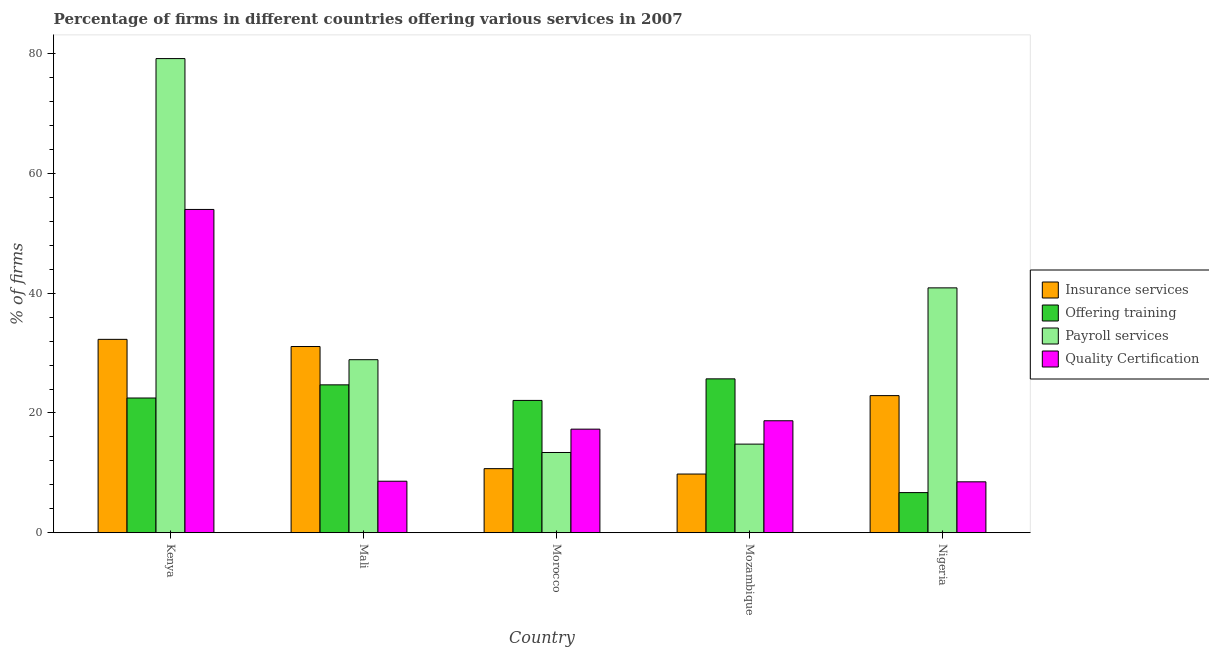How many different coloured bars are there?
Your answer should be compact. 4. Are the number of bars on each tick of the X-axis equal?
Provide a short and direct response. Yes. What is the label of the 3rd group of bars from the left?
Your response must be concise. Morocco. In how many cases, is the number of bars for a given country not equal to the number of legend labels?
Your answer should be very brief. 0. What is the percentage of firms offering payroll services in Mali?
Make the answer very short. 28.9. Across all countries, what is the maximum percentage of firms offering training?
Your answer should be compact. 25.7. Across all countries, what is the minimum percentage of firms offering insurance services?
Provide a succinct answer. 9.8. In which country was the percentage of firms offering quality certification maximum?
Your answer should be compact. Kenya. In which country was the percentage of firms offering quality certification minimum?
Your response must be concise. Nigeria. What is the total percentage of firms offering training in the graph?
Keep it short and to the point. 101.7. What is the difference between the percentage of firms offering quality certification in Kenya and that in Morocco?
Your answer should be very brief. 36.7. What is the difference between the percentage of firms offering training in Mali and the percentage of firms offering quality certification in Nigeria?
Offer a very short reply. 16.2. What is the average percentage of firms offering insurance services per country?
Offer a terse response. 21.36. What is the difference between the percentage of firms offering training and percentage of firms offering payroll services in Mozambique?
Your answer should be very brief. 10.9. What is the ratio of the percentage of firms offering quality certification in Mali to that in Mozambique?
Offer a very short reply. 0.46. Is the percentage of firms offering payroll services in Mali less than that in Morocco?
Make the answer very short. No. Is the difference between the percentage of firms offering training in Kenya and Mozambique greater than the difference between the percentage of firms offering payroll services in Kenya and Mozambique?
Provide a succinct answer. No. What is the difference between the highest and the second highest percentage of firms offering quality certification?
Make the answer very short. 35.3. What is the difference between the highest and the lowest percentage of firms offering quality certification?
Offer a terse response. 45.5. In how many countries, is the percentage of firms offering insurance services greater than the average percentage of firms offering insurance services taken over all countries?
Give a very brief answer. 3. What does the 2nd bar from the left in Kenya represents?
Ensure brevity in your answer.  Offering training. What does the 2nd bar from the right in Morocco represents?
Make the answer very short. Payroll services. How many bars are there?
Your answer should be very brief. 20. How many countries are there in the graph?
Provide a short and direct response. 5. What is the difference between two consecutive major ticks on the Y-axis?
Your answer should be compact. 20. Does the graph contain grids?
Your answer should be compact. No. How many legend labels are there?
Your answer should be compact. 4. How are the legend labels stacked?
Your response must be concise. Vertical. What is the title of the graph?
Ensure brevity in your answer.  Percentage of firms in different countries offering various services in 2007. Does "Self-employed" appear as one of the legend labels in the graph?
Make the answer very short. No. What is the label or title of the Y-axis?
Ensure brevity in your answer.  % of firms. What is the % of firms of Insurance services in Kenya?
Provide a short and direct response. 32.3. What is the % of firms of Payroll services in Kenya?
Give a very brief answer. 79.2. What is the % of firms in Insurance services in Mali?
Keep it short and to the point. 31.1. What is the % of firms of Offering training in Mali?
Give a very brief answer. 24.7. What is the % of firms of Payroll services in Mali?
Provide a succinct answer. 28.9. What is the % of firms in Insurance services in Morocco?
Provide a short and direct response. 10.7. What is the % of firms in Offering training in Morocco?
Offer a terse response. 22.1. What is the % of firms of Insurance services in Mozambique?
Ensure brevity in your answer.  9.8. What is the % of firms in Offering training in Mozambique?
Your answer should be very brief. 25.7. What is the % of firms of Quality Certification in Mozambique?
Ensure brevity in your answer.  18.7. What is the % of firms of Insurance services in Nigeria?
Make the answer very short. 22.9. What is the % of firms of Offering training in Nigeria?
Ensure brevity in your answer.  6.7. What is the % of firms of Payroll services in Nigeria?
Make the answer very short. 40.9. Across all countries, what is the maximum % of firms in Insurance services?
Give a very brief answer. 32.3. Across all countries, what is the maximum % of firms of Offering training?
Provide a succinct answer. 25.7. Across all countries, what is the maximum % of firms in Payroll services?
Ensure brevity in your answer.  79.2. Across all countries, what is the minimum % of firms in Insurance services?
Your response must be concise. 9.8. Across all countries, what is the minimum % of firms of Offering training?
Your answer should be very brief. 6.7. Across all countries, what is the minimum % of firms in Payroll services?
Offer a terse response. 13.4. Across all countries, what is the minimum % of firms of Quality Certification?
Offer a terse response. 8.5. What is the total % of firms of Insurance services in the graph?
Provide a short and direct response. 106.8. What is the total % of firms in Offering training in the graph?
Keep it short and to the point. 101.7. What is the total % of firms of Payroll services in the graph?
Offer a terse response. 177.2. What is the total % of firms of Quality Certification in the graph?
Make the answer very short. 107.1. What is the difference between the % of firms of Offering training in Kenya and that in Mali?
Your response must be concise. -2.2. What is the difference between the % of firms in Payroll services in Kenya and that in Mali?
Keep it short and to the point. 50.3. What is the difference between the % of firms in Quality Certification in Kenya and that in Mali?
Your answer should be very brief. 45.4. What is the difference between the % of firms of Insurance services in Kenya and that in Morocco?
Make the answer very short. 21.6. What is the difference between the % of firms in Payroll services in Kenya and that in Morocco?
Make the answer very short. 65.8. What is the difference between the % of firms of Quality Certification in Kenya and that in Morocco?
Offer a terse response. 36.7. What is the difference between the % of firms in Insurance services in Kenya and that in Mozambique?
Provide a succinct answer. 22.5. What is the difference between the % of firms in Payroll services in Kenya and that in Mozambique?
Offer a very short reply. 64.4. What is the difference between the % of firms of Quality Certification in Kenya and that in Mozambique?
Provide a short and direct response. 35.3. What is the difference between the % of firms of Payroll services in Kenya and that in Nigeria?
Your answer should be compact. 38.3. What is the difference between the % of firms in Quality Certification in Kenya and that in Nigeria?
Provide a succinct answer. 45.5. What is the difference between the % of firms of Insurance services in Mali and that in Morocco?
Offer a very short reply. 20.4. What is the difference between the % of firms of Offering training in Mali and that in Morocco?
Provide a succinct answer. 2.6. What is the difference between the % of firms in Quality Certification in Mali and that in Morocco?
Give a very brief answer. -8.7. What is the difference between the % of firms in Insurance services in Mali and that in Mozambique?
Provide a short and direct response. 21.3. What is the difference between the % of firms of Payroll services in Mali and that in Mozambique?
Give a very brief answer. 14.1. What is the difference between the % of firms in Quality Certification in Mali and that in Mozambique?
Your response must be concise. -10.1. What is the difference between the % of firms in Insurance services in Mali and that in Nigeria?
Provide a succinct answer. 8.2. What is the difference between the % of firms in Payroll services in Mali and that in Nigeria?
Your answer should be compact. -12. What is the difference between the % of firms of Quality Certification in Mali and that in Nigeria?
Your response must be concise. 0.1. What is the difference between the % of firms in Quality Certification in Morocco and that in Mozambique?
Give a very brief answer. -1.4. What is the difference between the % of firms in Payroll services in Morocco and that in Nigeria?
Make the answer very short. -27.5. What is the difference between the % of firms in Quality Certification in Morocco and that in Nigeria?
Offer a terse response. 8.8. What is the difference between the % of firms in Payroll services in Mozambique and that in Nigeria?
Give a very brief answer. -26.1. What is the difference between the % of firms in Insurance services in Kenya and the % of firms in Offering training in Mali?
Ensure brevity in your answer.  7.6. What is the difference between the % of firms in Insurance services in Kenya and the % of firms in Quality Certification in Mali?
Ensure brevity in your answer.  23.7. What is the difference between the % of firms of Offering training in Kenya and the % of firms of Quality Certification in Mali?
Your response must be concise. 13.9. What is the difference between the % of firms of Payroll services in Kenya and the % of firms of Quality Certification in Mali?
Offer a very short reply. 70.6. What is the difference between the % of firms in Insurance services in Kenya and the % of firms in Offering training in Morocco?
Your response must be concise. 10.2. What is the difference between the % of firms in Insurance services in Kenya and the % of firms in Quality Certification in Morocco?
Offer a terse response. 15. What is the difference between the % of firms in Payroll services in Kenya and the % of firms in Quality Certification in Morocco?
Your answer should be compact. 61.9. What is the difference between the % of firms of Insurance services in Kenya and the % of firms of Offering training in Mozambique?
Provide a succinct answer. 6.6. What is the difference between the % of firms in Insurance services in Kenya and the % of firms in Payroll services in Mozambique?
Make the answer very short. 17.5. What is the difference between the % of firms in Insurance services in Kenya and the % of firms in Quality Certification in Mozambique?
Your answer should be compact. 13.6. What is the difference between the % of firms of Offering training in Kenya and the % of firms of Payroll services in Mozambique?
Offer a terse response. 7.7. What is the difference between the % of firms of Offering training in Kenya and the % of firms of Quality Certification in Mozambique?
Keep it short and to the point. 3.8. What is the difference between the % of firms in Payroll services in Kenya and the % of firms in Quality Certification in Mozambique?
Offer a terse response. 60.5. What is the difference between the % of firms of Insurance services in Kenya and the % of firms of Offering training in Nigeria?
Keep it short and to the point. 25.6. What is the difference between the % of firms in Insurance services in Kenya and the % of firms in Payroll services in Nigeria?
Keep it short and to the point. -8.6. What is the difference between the % of firms of Insurance services in Kenya and the % of firms of Quality Certification in Nigeria?
Make the answer very short. 23.8. What is the difference between the % of firms in Offering training in Kenya and the % of firms in Payroll services in Nigeria?
Ensure brevity in your answer.  -18.4. What is the difference between the % of firms of Payroll services in Kenya and the % of firms of Quality Certification in Nigeria?
Offer a terse response. 70.7. What is the difference between the % of firms of Insurance services in Mali and the % of firms of Quality Certification in Morocco?
Provide a succinct answer. 13.8. What is the difference between the % of firms in Payroll services in Mali and the % of firms in Quality Certification in Morocco?
Your answer should be very brief. 11.6. What is the difference between the % of firms in Insurance services in Mali and the % of firms in Offering training in Mozambique?
Provide a succinct answer. 5.4. What is the difference between the % of firms of Offering training in Mali and the % of firms of Quality Certification in Mozambique?
Your answer should be compact. 6. What is the difference between the % of firms of Payroll services in Mali and the % of firms of Quality Certification in Mozambique?
Offer a very short reply. 10.2. What is the difference between the % of firms in Insurance services in Mali and the % of firms in Offering training in Nigeria?
Your response must be concise. 24.4. What is the difference between the % of firms in Insurance services in Mali and the % of firms in Payroll services in Nigeria?
Make the answer very short. -9.8. What is the difference between the % of firms of Insurance services in Mali and the % of firms of Quality Certification in Nigeria?
Provide a succinct answer. 22.6. What is the difference between the % of firms in Offering training in Mali and the % of firms in Payroll services in Nigeria?
Your answer should be very brief. -16.2. What is the difference between the % of firms of Payroll services in Mali and the % of firms of Quality Certification in Nigeria?
Your answer should be compact. 20.4. What is the difference between the % of firms in Insurance services in Morocco and the % of firms in Offering training in Mozambique?
Keep it short and to the point. -15. What is the difference between the % of firms in Insurance services in Morocco and the % of firms in Payroll services in Mozambique?
Offer a very short reply. -4.1. What is the difference between the % of firms in Insurance services in Morocco and the % of firms in Offering training in Nigeria?
Provide a short and direct response. 4. What is the difference between the % of firms in Insurance services in Morocco and the % of firms in Payroll services in Nigeria?
Offer a terse response. -30.2. What is the difference between the % of firms of Insurance services in Morocco and the % of firms of Quality Certification in Nigeria?
Give a very brief answer. 2.2. What is the difference between the % of firms of Offering training in Morocco and the % of firms of Payroll services in Nigeria?
Your answer should be very brief. -18.8. What is the difference between the % of firms in Offering training in Morocco and the % of firms in Quality Certification in Nigeria?
Provide a succinct answer. 13.6. What is the difference between the % of firms in Insurance services in Mozambique and the % of firms in Offering training in Nigeria?
Provide a succinct answer. 3.1. What is the difference between the % of firms of Insurance services in Mozambique and the % of firms of Payroll services in Nigeria?
Your answer should be compact. -31.1. What is the difference between the % of firms in Offering training in Mozambique and the % of firms in Payroll services in Nigeria?
Your answer should be very brief. -15.2. What is the average % of firms of Insurance services per country?
Offer a terse response. 21.36. What is the average % of firms of Offering training per country?
Offer a terse response. 20.34. What is the average % of firms of Payroll services per country?
Offer a terse response. 35.44. What is the average % of firms in Quality Certification per country?
Your response must be concise. 21.42. What is the difference between the % of firms of Insurance services and % of firms of Offering training in Kenya?
Make the answer very short. 9.8. What is the difference between the % of firms in Insurance services and % of firms in Payroll services in Kenya?
Provide a succinct answer. -46.9. What is the difference between the % of firms in Insurance services and % of firms in Quality Certification in Kenya?
Your answer should be compact. -21.7. What is the difference between the % of firms in Offering training and % of firms in Payroll services in Kenya?
Keep it short and to the point. -56.7. What is the difference between the % of firms of Offering training and % of firms of Quality Certification in Kenya?
Offer a terse response. -31.5. What is the difference between the % of firms in Payroll services and % of firms in Quality Certification in Kenya?
Provide a short and direct response. 25.2. What is the difference between the % of firms of Insurance services and % of firms of Offering training in Mali?
Ensure brevity in your answer.  6.4. What is the difference between the % of firms in Offering training and % of firms in Payroll services in Mali?
Keep it short and to the point. -4.2. What is the difference between the % of firms in Offering training and % of firms in Quality Certification in Mali?
Ensure brevity in your answer.  16.1. What is the difference between the % of firms in Payroll services and % of firms in Quality Certification in Mali?
Give a very brief answer. 20.3. What is the difference between the % of firms of Insurance services and % of firms of Offering training in Morocco?
Provide a succinct answer. -11.4. What is the difference between the % of firms of Insurance services and % of firms of Payroll services in Morocco?
Make the answer very short. -2.7. What is the difference between the % of firms of Insurance services and % of firms of Quality Certification in Morocco?
Your answer should be very brief. -6.6. What is the difference between the % of firms of Offering training and % of firms of Quality Certification in Morocco?
Ensure brevity in your answer.  4.8. What is the difference between the % of firms of Insurance services and % of firms of Offering training in Mozambique?
Make the answer very short. -15.9. What is the difference between the % of firms of Insurance services and % of firms of Quality Certification in Mozambique?
Give a very brief answer. -8.9. What is the difference between the % of firms in Offering training and % of firms in Payroll services in Mozambique?
Offer a terse response. 10.9. What is the difference between the % of firms in Offering training and % of firms in Quality Certification in Mozambique?
Your response must be concise. 7. What is the difference between the % of firms of Insurance services and % of firms of Offering training in Nigeria?
Your response must be concise. 16.2. What is the difference between the % of firms in Insurance services and % of firms in Payroll services in Nigeria?
Give a very brief answer. -18. What is the difference between the % of firms of Insurance services and % of firms of Quality Certification in Nigeria?
Your response must be concise. 14.4. What is the difference between the % of firms of Offering training and % of firms of Payroll services in Nigeria?
Ensure brevity in your answer.  -34.2. What is the difference between the % of firms in Offering training and % of firms in Quality Certification in Nigeria?
Your response must be concise. -1.8. What is the difference between the % of firms of Payroll services and % of firms of Quality Certification in Nigeria?
Keep it short and to the point. 32.4. What is the ratio of the % of firms in Insurance services in Kenya to that in Mali?
Your answer should be very brief. 1.04. What is the ratio of the % of firms of Offering training in Kenya to that in Mali?
Make the answer very short. 0.91. What is the ratio of the % of firms in Payroll services in Kenya to that in Mali?
Your response must be concise. 2.74. What is the ratio of the % of firms in Quality Certification in Kenya to that in Mali?
Offer a very short reply. 6.28. What is the ratio of the % of firms in Insurance services in Kenya to that in Morocco?
Your answer should be very brief. 3.02. What is the ratio of the % of firms in Offering training in Kenya to that in Morocco?
Your answer should be compact. 1.02. What is the ratio of the % of firms in Payroll services in Kenya to that in Morocco?
Offer a terse response. 5.91. What is the ratio of the % of firms in Quality Certification in Kenya to that in Morocco?
Offer a very short reply. 3.12. What is the ratio of the % of firms of Insurance services in Kenya to that in Mozambique?
Keep it short and to the point. 3.3. What is the ratio of the % of firms in Offering training in Kenya to that in Mozambique?
Your response must be concise. 0.88. What is the ratio of the % of firms in Payroll services in Kenya to that in Mozambique?
Make the answer very short. 5.35. What is the ratio of the % of firms in Quality Certification in Kenya to that in Mozambique?
Offer a very short reply. 2.89. What is the ratio of the % of firms in Insurance services in Kenya to that in Nigeria?
Make the answer very short. 1.41. What is the ratio of the % of firms of Offering training in Kenya to that in Nigeria?
Provide a short and direct response. 3.36. What is the ratio of the % of firms in Payroll services in Kenya to that in Nigeria?
Your answer should be compact. 1.94. What is the ratio of the % of firms of Quality Certification in Kenya to that in Nigeria?
Provide a succinct answer. 6.35. What is the ratio of the % of firms in Insurance services in Mali to that in Morocco?
Offer a very short reply. 2.91. What is the ratio of the % of firms in Offering training in Mali to that in Morocco?
Give a very brief answer. 1.12. What is the ratio of the % of firms in Payroll services in Mali to that in Morocco?
Give a very brief answer. 2.16. What is the ratio of the % of firms of Quality Certification in Mali to that in Morocco?
Your answer should be compact. 0.5. What is the ratio of the % of firms in Insurance services in Mali to that in Mozambique?
Your response must be concise. 3.17. What is the ratio of the % of firms of Offering training in Mali to that in Mozambique?
Your response must be concise. 0.96. What is the ratio of the % of firms in Payroll services in Mali to that in Mozambique?
Ensure brevity in your answer.  1.95. What is the ratio of the % of firms of Quality Certification in Mali to that in Mozambique?
Provide a short and direct response. 0.46. What is the ratio of the % of firms of Insurance services in Mali to that in Nigeria?
Your answer should be compact. 1.36. What is the ratio of the % of firms of Offering training in Mali to that in Nigeria?
Give a very brief answer. 3.69. What is the ratio of the % of firms of Payroll services in Mali to that in Nigeria?
Offer a terse response. 0.71. What is the ratio of the % of firms in Quality Certification in Mali to that in Nigeria?
Keep it short and to the point. 1.01. What is the ratio of the % of firms of Insurance services in Morocco to that in Mozambique?
Keep it short and to the point. 1.09. What is the ratio of the % of firms of Offering training in Morocco to that in Mozambique?
Make the answer very short. 0.86. What is the ratio of the % of firms in Payroll services in Morocco to that in Mozambique?
Your answer should be very brief. 0.91. What is the ratio of the % of firms in Quality Certification in Morocco to that in Mozambique?
Ensure brevity in your answer.  0.93. What is the ratio of the % of firms of Insurance services in Morocco to that in Nigeria?
Offer a very short reply. 0.47. What is the ratio of the % of firms in Offering training in Morocco to that in Nigeria?
Provide a short and direct response. 3.3. What is the ratio of the % of firms of Payroll services in Morocco to that in Nigeria?
Your answer should be very brief. 0.33. What is the ratio of the % of firms of Quality Certification in Morocco to that in Nigeria?
Provide a short and direct response. 2.04. What is the ratio of the % of firms in Insurance services in Mozambique to that in Nigeria?
Ensure brevity in your answer.  0.43. What is the ratio of the % of firms of Offering training in Mozambique to that in Nigeria?
Provide a short and direct response. 3.84. What is the ratio of the % of firms of Payroll services in Mozambique to that in Nigeria?
Offer a very short reply. 0.36. What is the ratio of the % of firms in Quality Certification in Mozambique to that in Nigeria?
Offer a very short reply. 2.2. What is the difference between the highest and the second highest % of firms in Insurance services?
Provide a succinct answer. 1.2. What is the difference between the highest and the second highest % of firms in Payroll services?
Provide a succinct answer. 38.3. What is the difference between the highest and the second highest % of firms in Quality Certification?
Provide a succinct answer. 35.3. What is the difference between the highest and the lowest % of firms in Insurance services?
Offer a terse response. 22.5. What is the difference between the highest and the lowest % of firms in Offering training?
Ensure brevity in your answer.  19. What is the difference between the highest and the lowest % of firms of Payroll services?
Your response must be concise. 65.8. What is the difference between the highest and the lowest % of firms of Quality Certification?
Give a very brief answer. 45.5. 